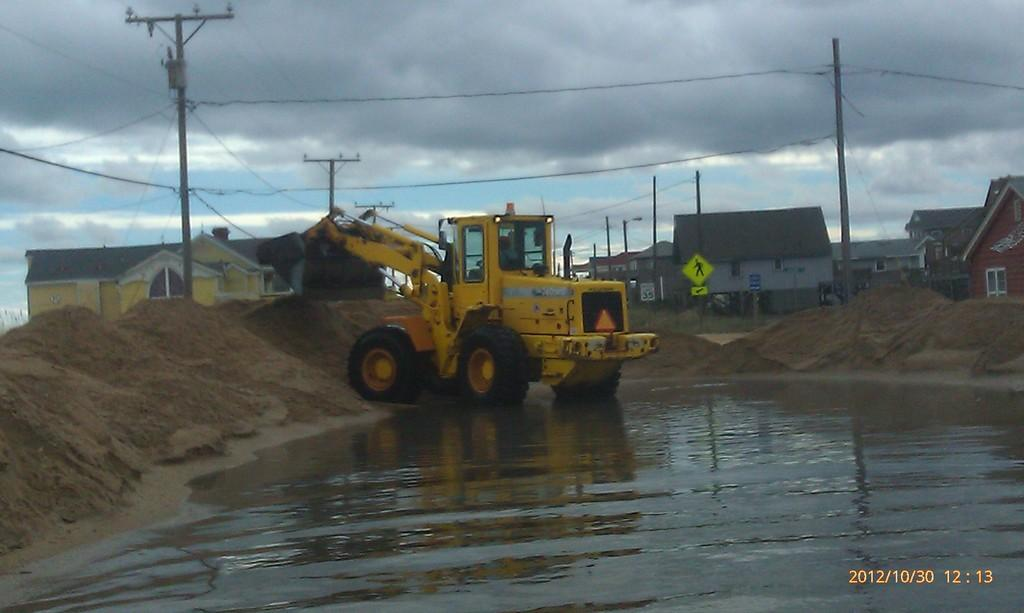<image>
Summarize the visual content of the image. Yellow tractor in the puddle that was taken on october 30th. 